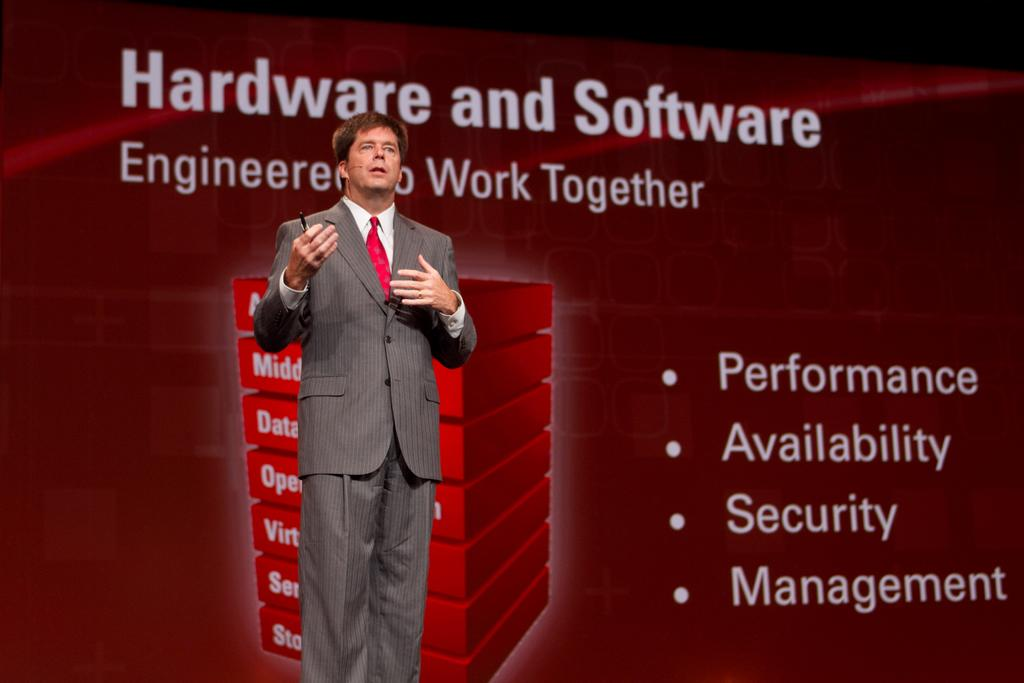What can be seen in the image? There is a person in the image. What is the person doing in the image? The person is holding an object. What can be seen in the background of the image? There is a background with text and images present in the image. How does the person wash the object in the image? There is no indication in the image that the person is washing the object, nor is there any visible water or cleaning supplies. 